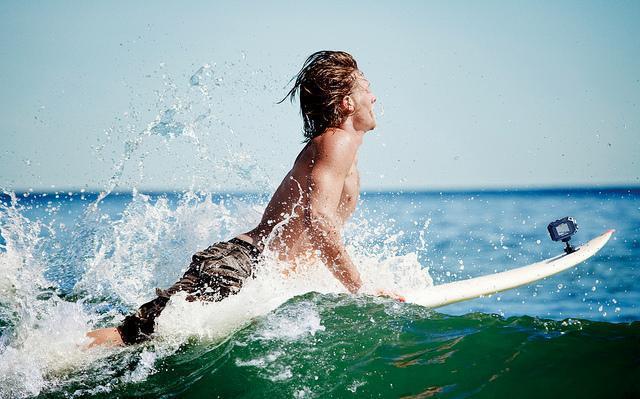How many horses are there?
Give a very brief answer. 0. 